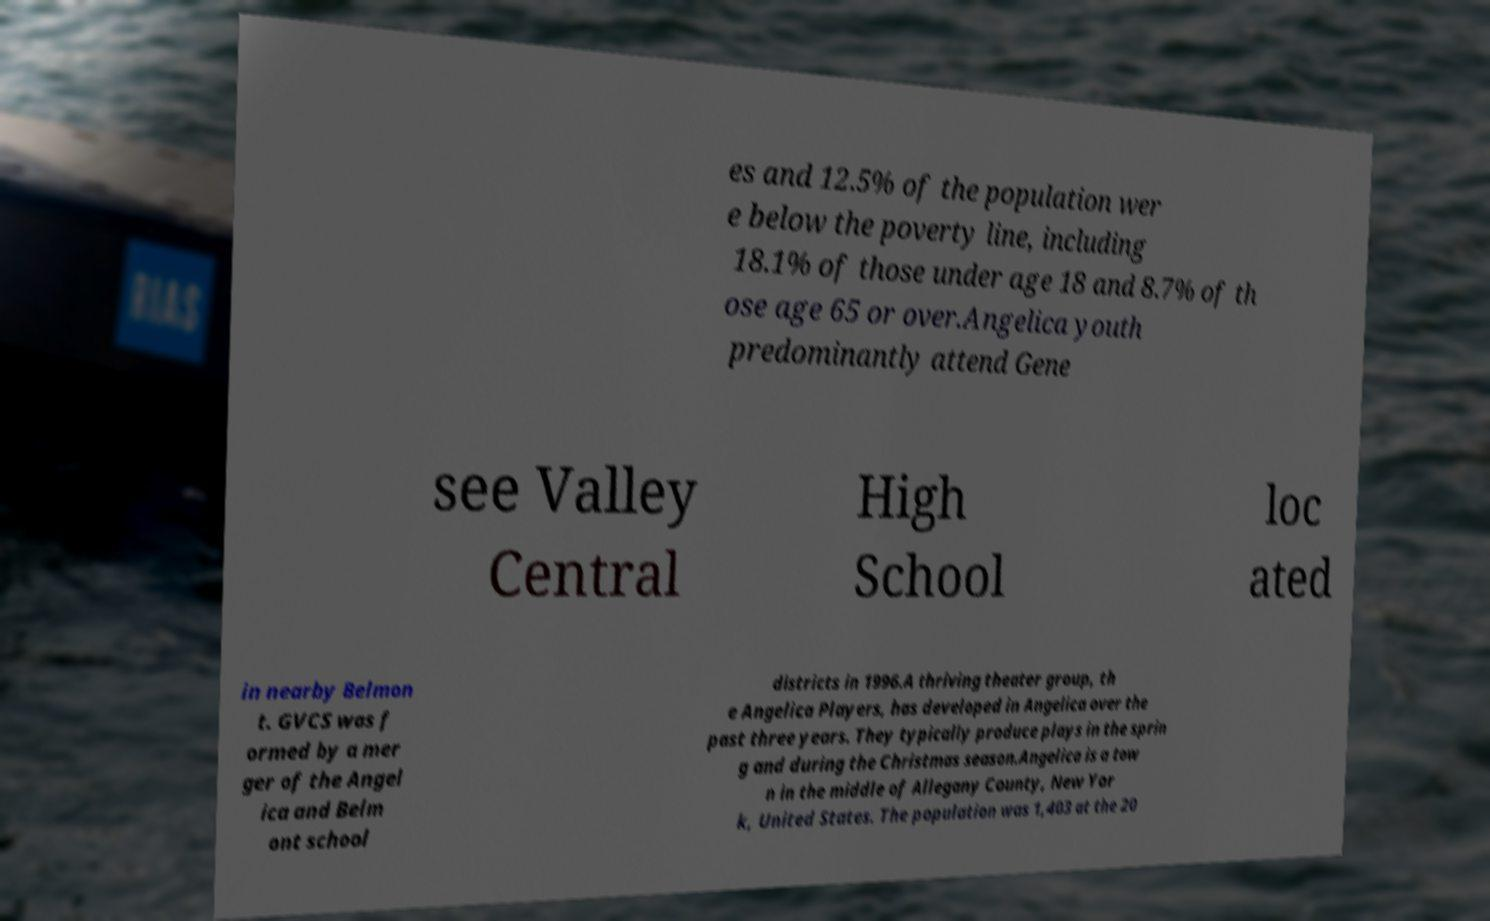There's text embedded in this image that I need extracted. Can you transcribe it verbatim? es and 12.5% of the population wer e below the poverty line, including 18.1% of those under age 18 and 8.7% of th ose age 65 or over.Angelica youth predominantly attend Gene see Valley Central High School loc ated in nearby Belmon t. GVCS was f ormed by a mer ger of the Angel ica and Belm ont school districts in 1996.A thriving theater group, th e Angelica Players, has developed in Angelica over the past three years. They typically produce plays in the sprin g and during the Christmas season.Angelica is a tow n in the middle of Allegany County, New Yor k, United States. The population was 1,403 at the 20 